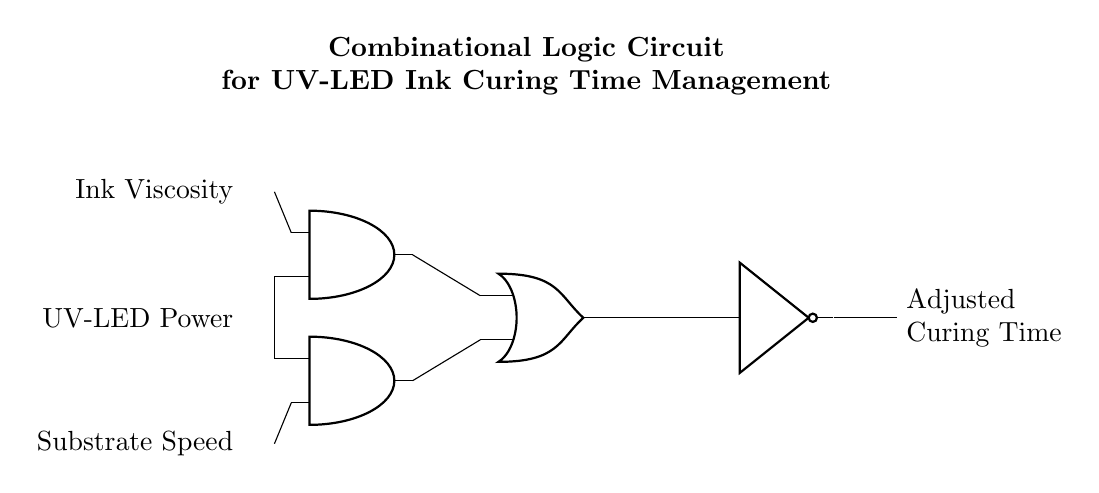What are the inputs to the circuit? The inputs are Ink Viscosity, UV-LED Power, and Substrate Speed, as labeled on the left side of the diagram.
Answer: Ink Viscosity, UV-LED Power, Substrate Speed How many AND gates are in this circuit? There are two AND gates shown in the diagram, as can be counted at the designated locations.
Answer: 2 What type of gate is located at the rightmost position in the circuit? The rightmost component is a NOT gate, indicated by its specific symbol in the diagram.
Answer: NOT gate What is the output of the OR gate? The output of the OR gate is directed to the input of the NOT gate, affecting the final output labeled as Adjusted Curing Time.
Answer: Adjusted Curing Time What condition must be met for the OR gate to output a high signal? If at least one of the outputs from the AND gates provides a high signal, which would occur when their corresponding input conditions are met.
Answer: At least one high signal Explain the relationship between the AND gates and the OR gate in this circuit. The two AND gates perform checks on their inputs; their outputs feed into the OR gate, which provides a final output based on those combined conditions, indicating the processing of curing time.
Answer: They provide combined output conditions 